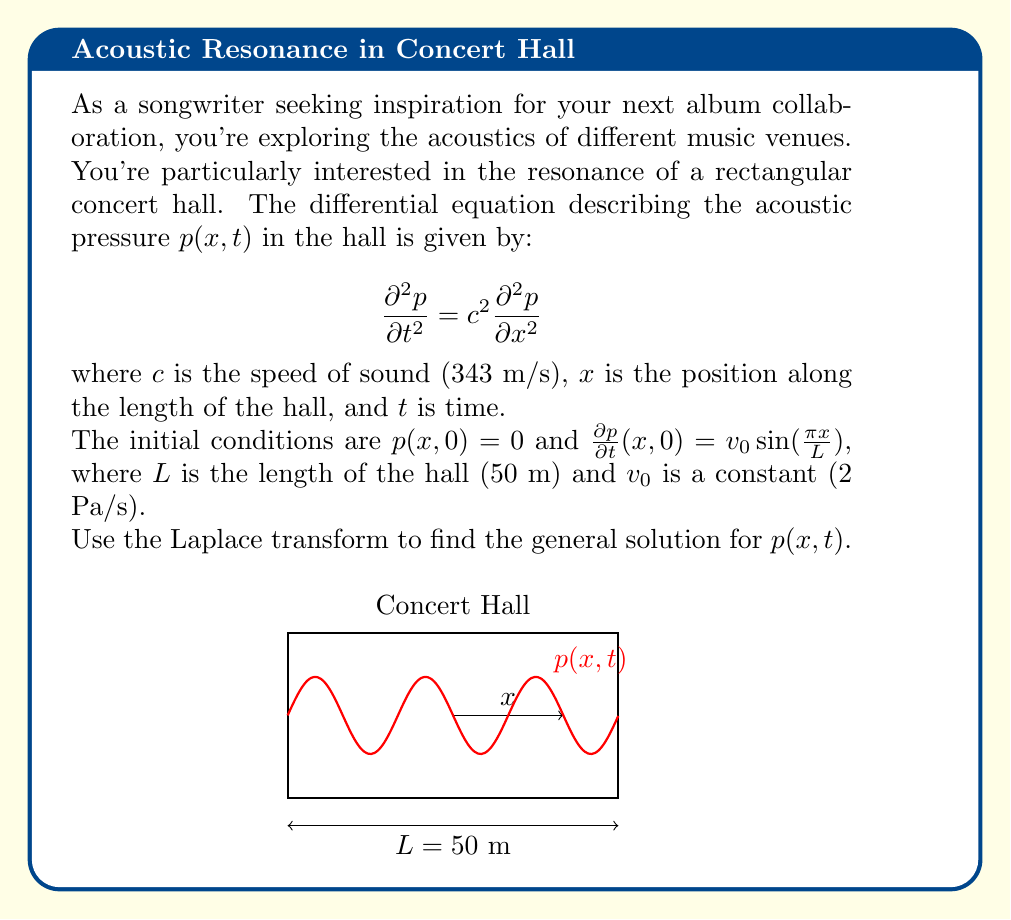Teach me how to tackle this problem. Let's solve this step-by-step using the Laplace transform method:

1) Take the Laplace transform of both sides of the equation with respect to $t$:
   $$\mathcal{L}\{\frac{\partial^2 p}{\partial t^2}\} = c^2 \mathcal{L}\{\frac{\partial^2 p}{\partial x^2}\}$$

2) Using the Laplace transform properties:
   $$s^2P(x,s) - sp(x,0) - \frac{\partial p}{\partial t}(x,0) = c^2\frac{\partial^2 P}{\partial x^2}(x,s)$$
   where $P(x,s)$ is the Laplace transform of $p(x,t)$.

3) Substitute the initial conditions:
   $$s^2P(x,s) - 0 - v_0 \sin(\frac{\pi x}{L}) = c^2\frac{\partial^2 P}{\partial x^2}(x,s)$$

4) Rearrange:
   $$\frac{\partial^2 P}{\partial x^2}(x,s) - \frac{s^2}{c^2}P(x,s) = -\frac{v_0}{c^2} \sin(\frac{\pi x}{L})$$

5) This is a non-homogeneous second-order ODE. The general solution is the sum of the homogeneous solution and a particular solution.

6) The homogeneous solution has the form:
   $$P_h(x,s) = A(s)\cosh(\frac{sx}{c}) + B(s)\sinh(\frac{sx}{c})$$

7) A particular solution can be found using the method of undetermined coefficients:
   $$P_p(x,s) = C(s)\sin(\frac{\pi x}{L})$$

8) Substitute this into the ODE:
   $$C(s)[-(\frac{\pi}{L})^2 - \frac{s^2}{c^2}]\sin(\frac{\pi x}{L}) = -\frac{v_0}{c^2} \sin(\frac{\pi x}{L})$$

9) Solve for $C(s)$:
   $$C(s) = \frac{v_0}{c^2[(\frac{\pi}{L})^2 + \frac{s^2}{c^2}]}$$

10) The general solution in the s-domain is:
    $$P(x,s) = A(s)\cosh(\frac{sx}{c}) + B(s)\sinh(\frac{sx}{c}) + \frac{v_0}{c^2[(\frac{\pi}{L})^2 + \frac{s^2}{c^2}]}\sin(\frac{\pi x}{L})$$

11) To find $A(s)$ and $B(s)$, we need boundary conditions, which are not provided. However, we can take the inverse Laplace transform of the particular solution:

    $$p_p(x,t) = \mathcal{L}^{-1}\{\frac{v_0}{c^2[(\frac{\pi}{L})^2 + \frac{s^2}{c^2}]}\}\sin(\frac{\pi x}{L})$$
    $$= \frac{v_0L}{\pi c}\sin(\frac{\pi ct}{L})\sin(\frac{\pi x}{L})$$

12) The general solution in the time domain is:
    $$p(x,t) = f(x,t) + \frac{v_0L}{\pi c}\sin(\frac{\pi ct}{L})\sin(\frac{\pi x}{L})$$
    where $f(x,t)$ is the inverse Laplace transform of the homogeneous solution.
Answer: $$p(x,t) = f(x,t) + \frac{v_0L}{\pi c}\sin(\frac{\pi ct}{L})\sin(\frac{\pi x}{L})$$ 